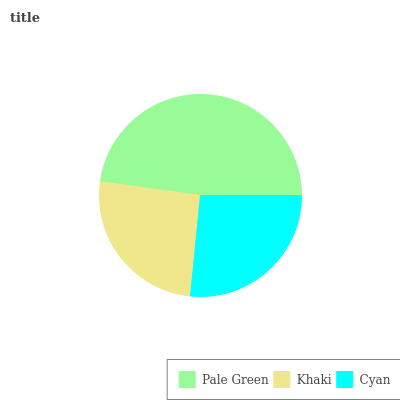Is Khaki the minimum?
Answer yes or no. Yes. Is Pale Green the maximum?
Answer yes or no. Yes. Is Cyan the minimum?
Answer yes or no. No. Is Cyan the maximum?
Answer yes or no. No. Is Cyan greater than Khaki?
Answer yes or no. Yes. Is Khaki less than Cyan?
Answer yes or no. Yes. Is Khaki greater than Cyan?
Answer yes or no. No. Is Cyan less than Khaki?
Answer yes or no. No. Is Cyan the high median?
Answer yes or no. Yes. Is Cyan the low median?
Answer yes or no. Yes. Is Khaki the high median?
Answer yes or no. No. Is Pale Green the low median?
Answer yes or no. No. 